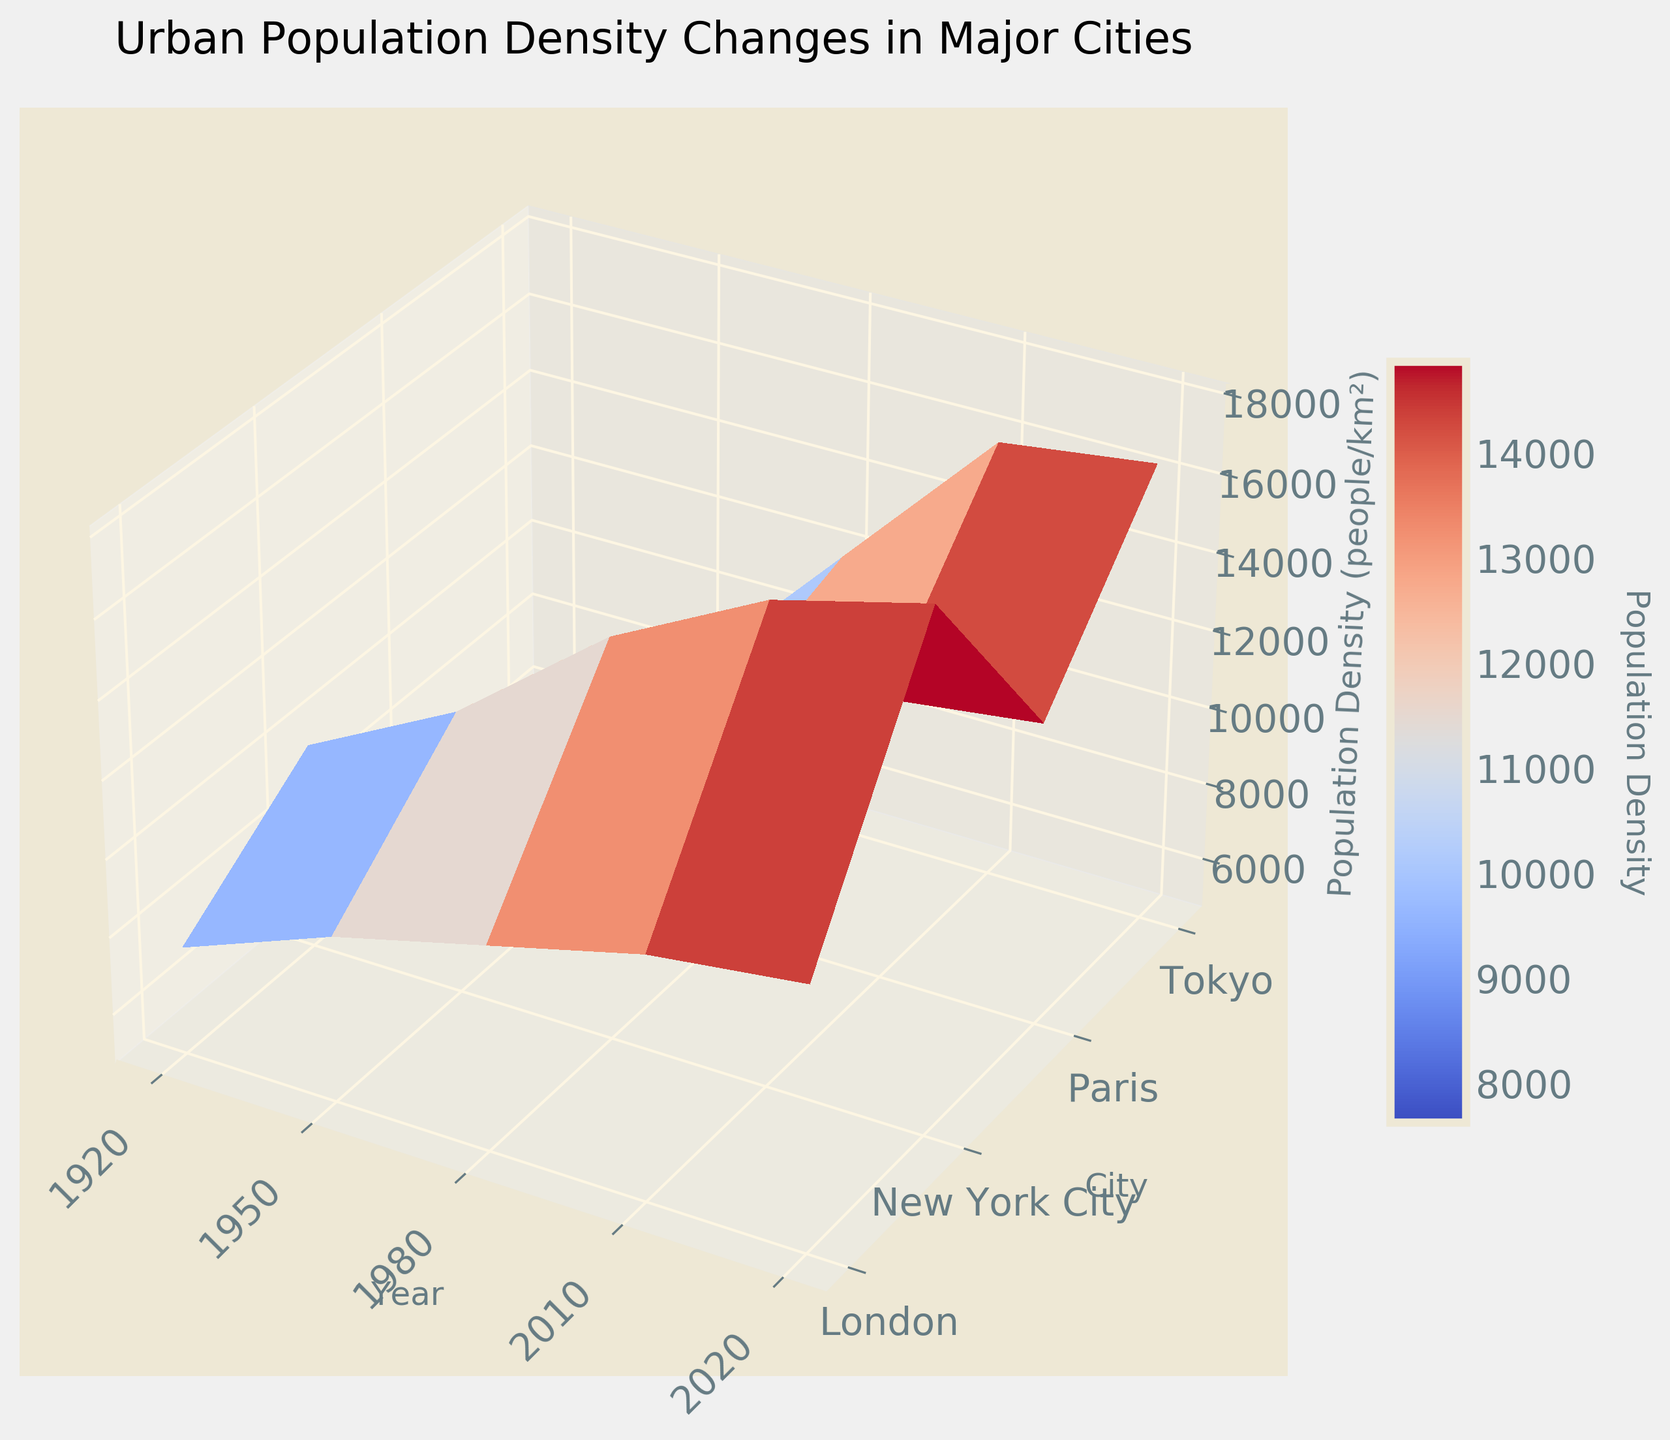What is the title of the plot? The title of the plot is usually located at the top of the figure. For this plot, it reads "Urban Population Density Changes in Major Cities"
Answer: Urban Population Density Changes in Major Cities What do the X-axis and Y-axis represent? The axes labels provide this information. The X-axis is labeled "Year," indicating it represents different years. The Y-axis is labeled "City," indicating it represents different major cities
Answer: Year and City Which city had the highest population density in 1920? By observing the surface plot at the position corresponding to the year 1920, we can see which city's population density (Z-axis) is the highest. New York City shows the highest peak in that year
Answer: New York City How has the population density of Tokyo changed from 1920 to 2020? Trace along the Y-axis for Tokyo while moving across the X-axis from 1920 to 2020, noting the increasing height on the Z-axis. The density for Tokyo has progressively increased from 5000 to 16500 people/km²
Answer: Increased In which year did New York City experience the most significant increase in population density? Look at the Z-values for New York City across the years on the X-axis and identify the interval with the steepest rise. The most significant increase appears from 1950 to 1980
Answer: From 1950 to 1980 Which city had a higher population density in 1950, London or Paris? Compare the heights on the Z-axis at the 1950 mark for both London and Paris. From the plot, Paris has a higher peak in 1950
Answer: Paris What is the average population density of all four cities combined in 2020? Look at the Z-axis values for all cities in 2020: New York City (18000), London (11500), Tokyo (16500), Paris (12500). Calculate the average: (18000 + 11500 + 16500 + 12500) / 4 = 14625
Answer: 14625 Between 1980 and 2010, which city shows a smaller increase in population density, London or Paris? By comparing the Z-axis values for 1980 and 2010, calculate the differences for London (11000 - 10000 = 1000) and Paris (12000 - 11000 = 1000). Both show the same increase
Answer: London and Paris show the same increase Which major city shows the lowest population density in the entire data set? Identify the lowest height on the Z-axis across all cities and years. Tokyo in 1920 has the lowest density of 5000 people/km²
Answer: Tokyo in 1920 